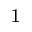<formula> <loc_0><loc_0><loc_500><loc_500>^ { 1 }</formula> 